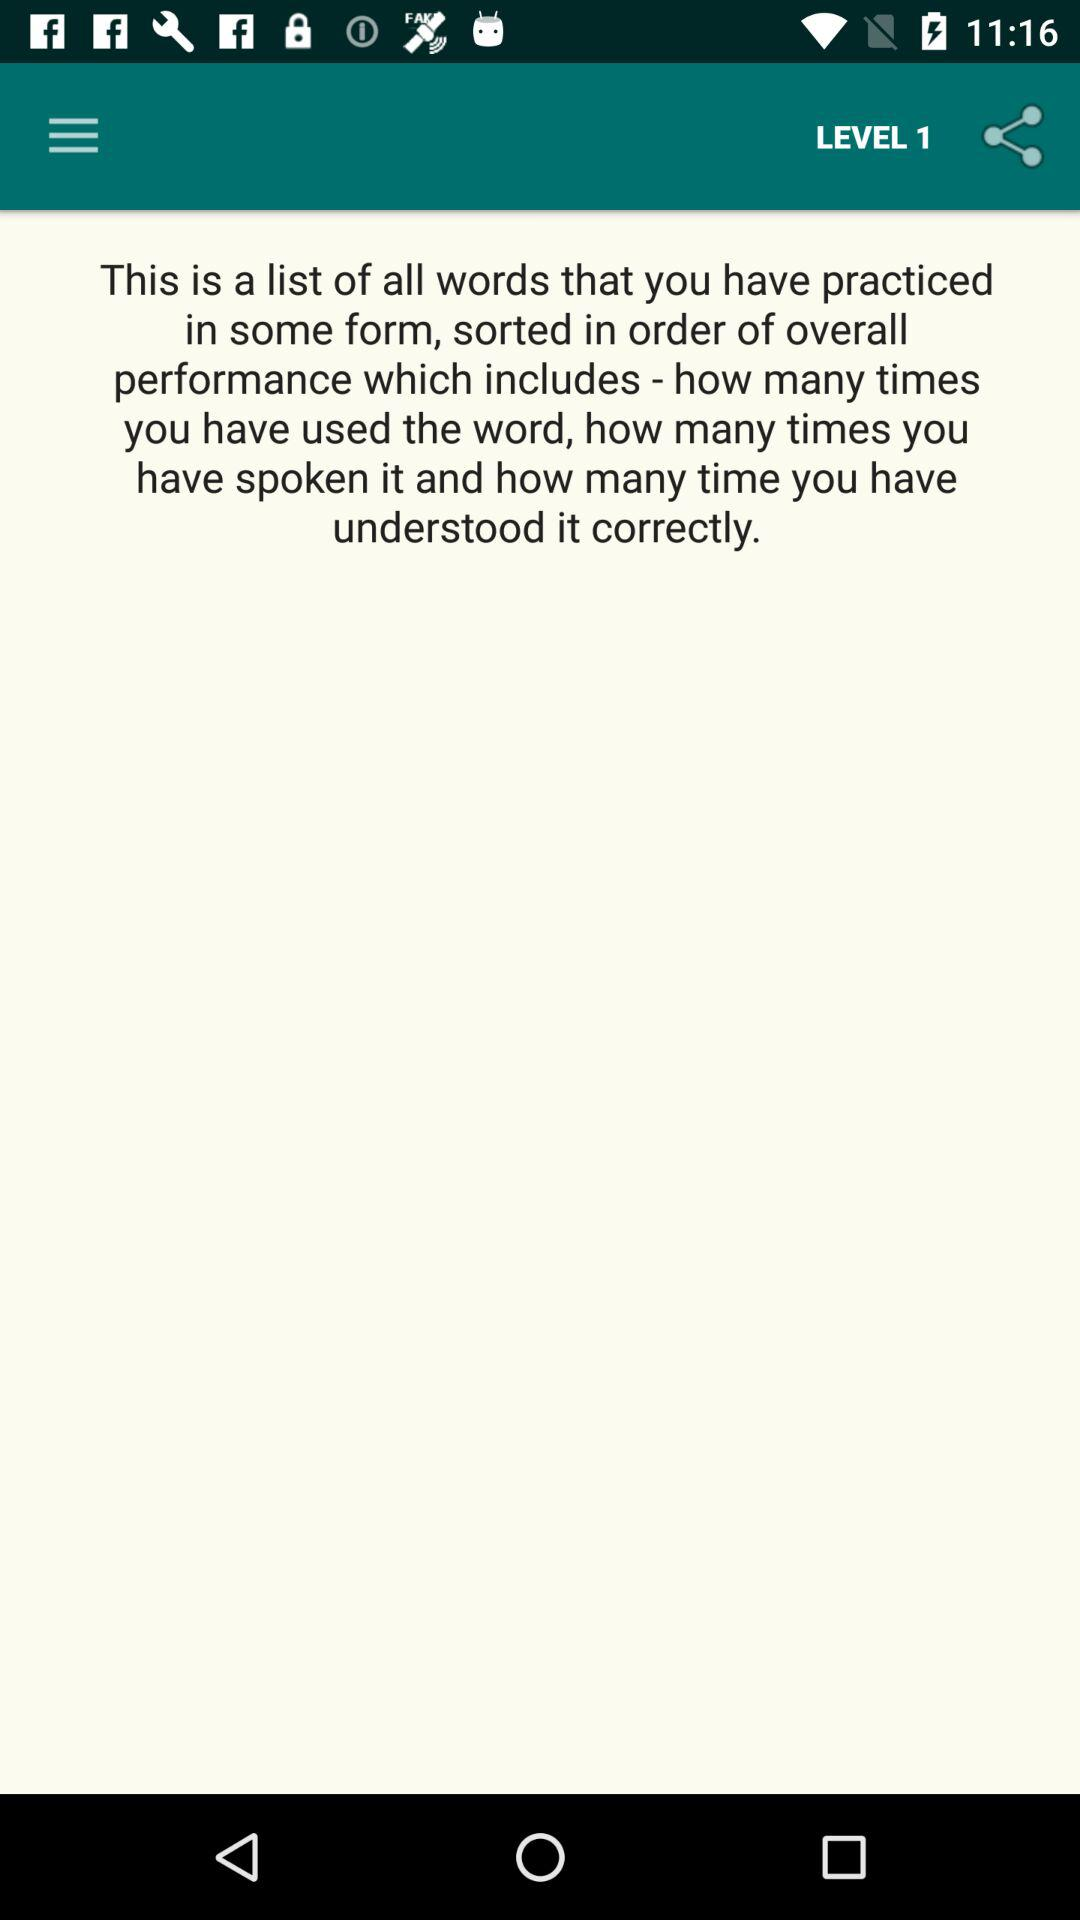At what level are we? You are on level 1. 